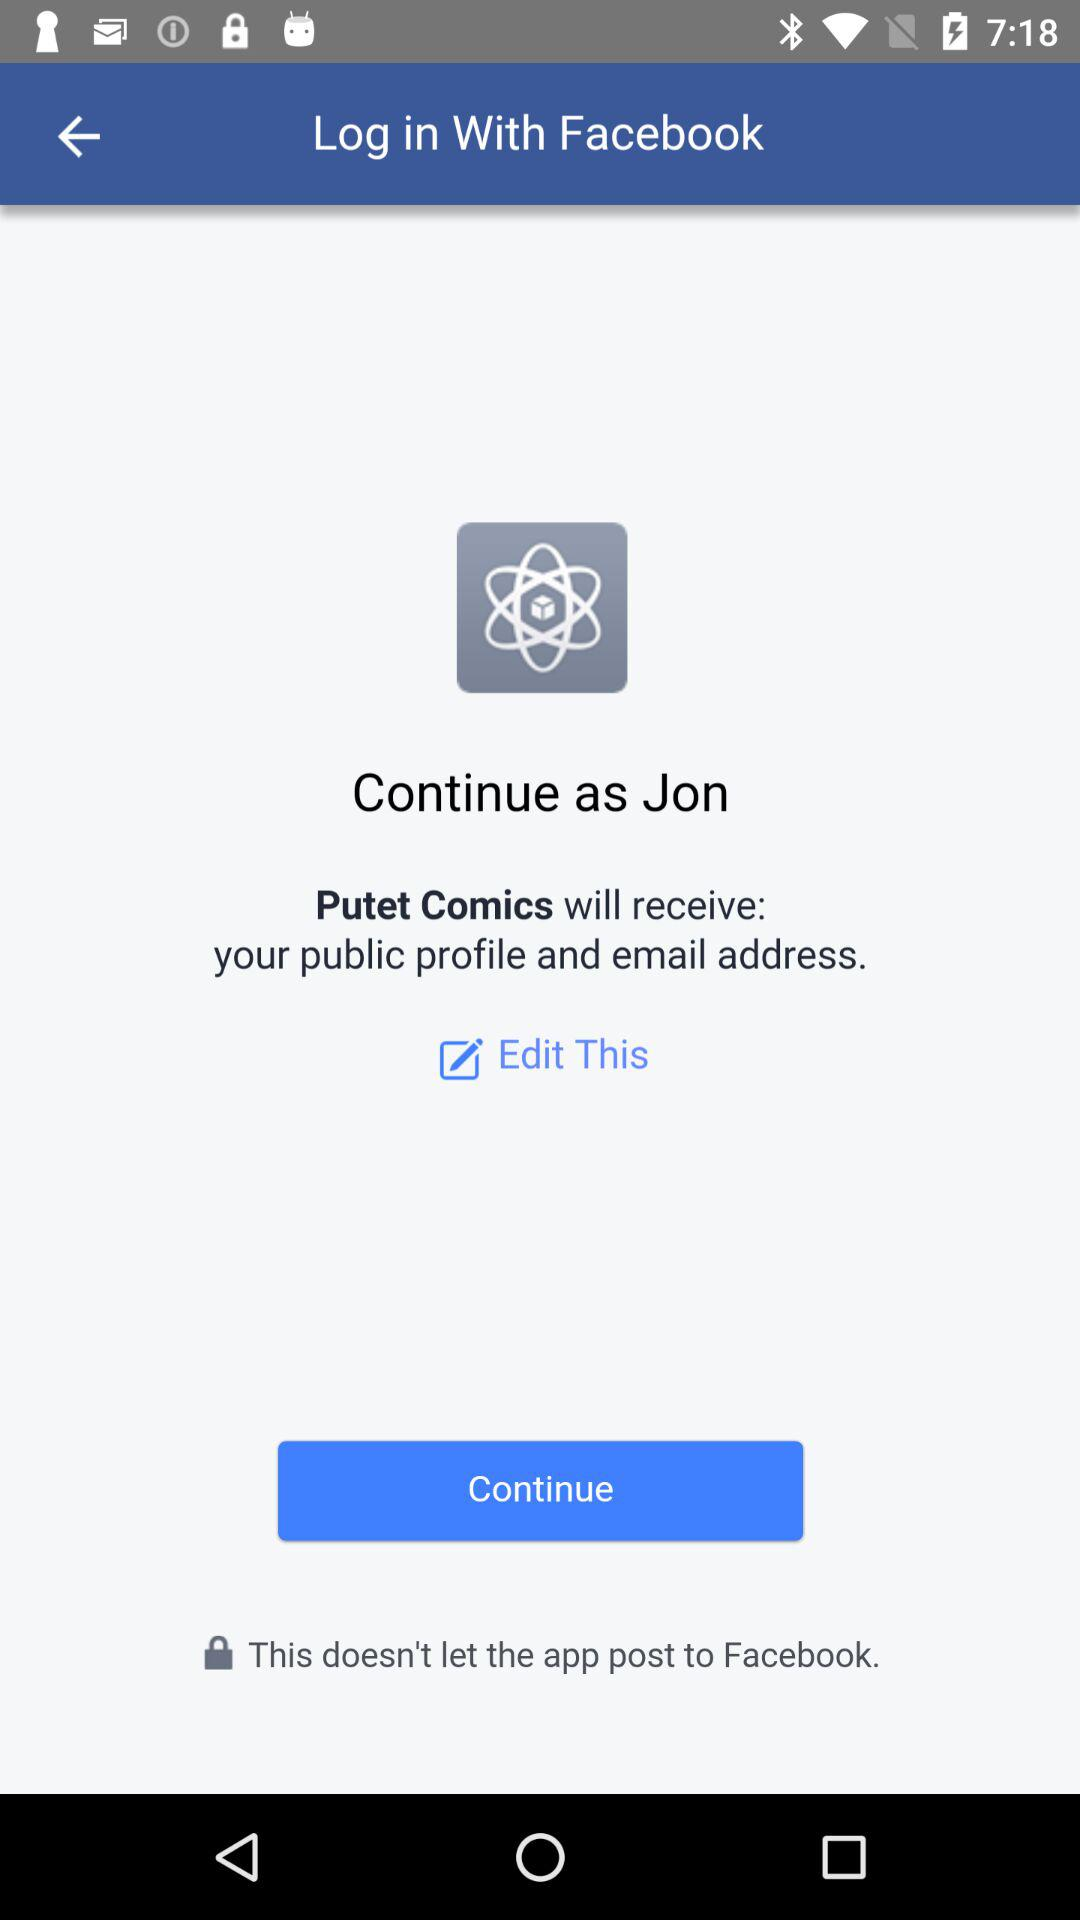Which information will "Putet Comics" receive? It will receive your public profile and email address. 